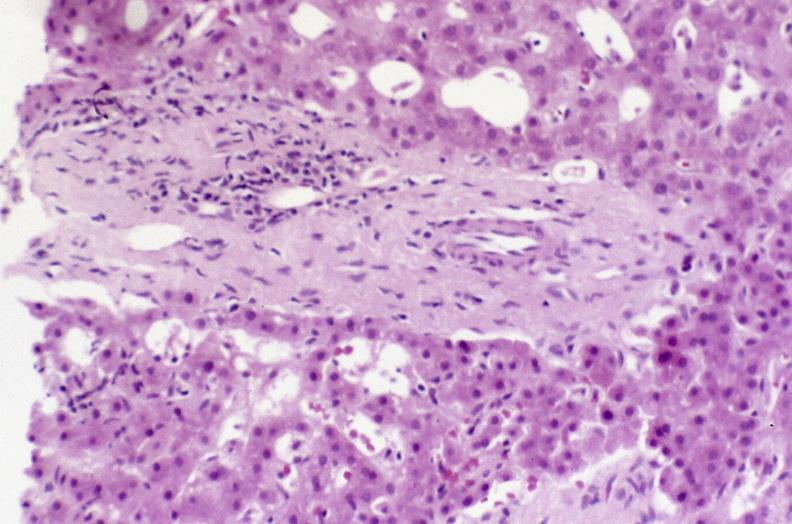what does this image show?
Answer the question using a single word or phrase. Recovery of ducts 